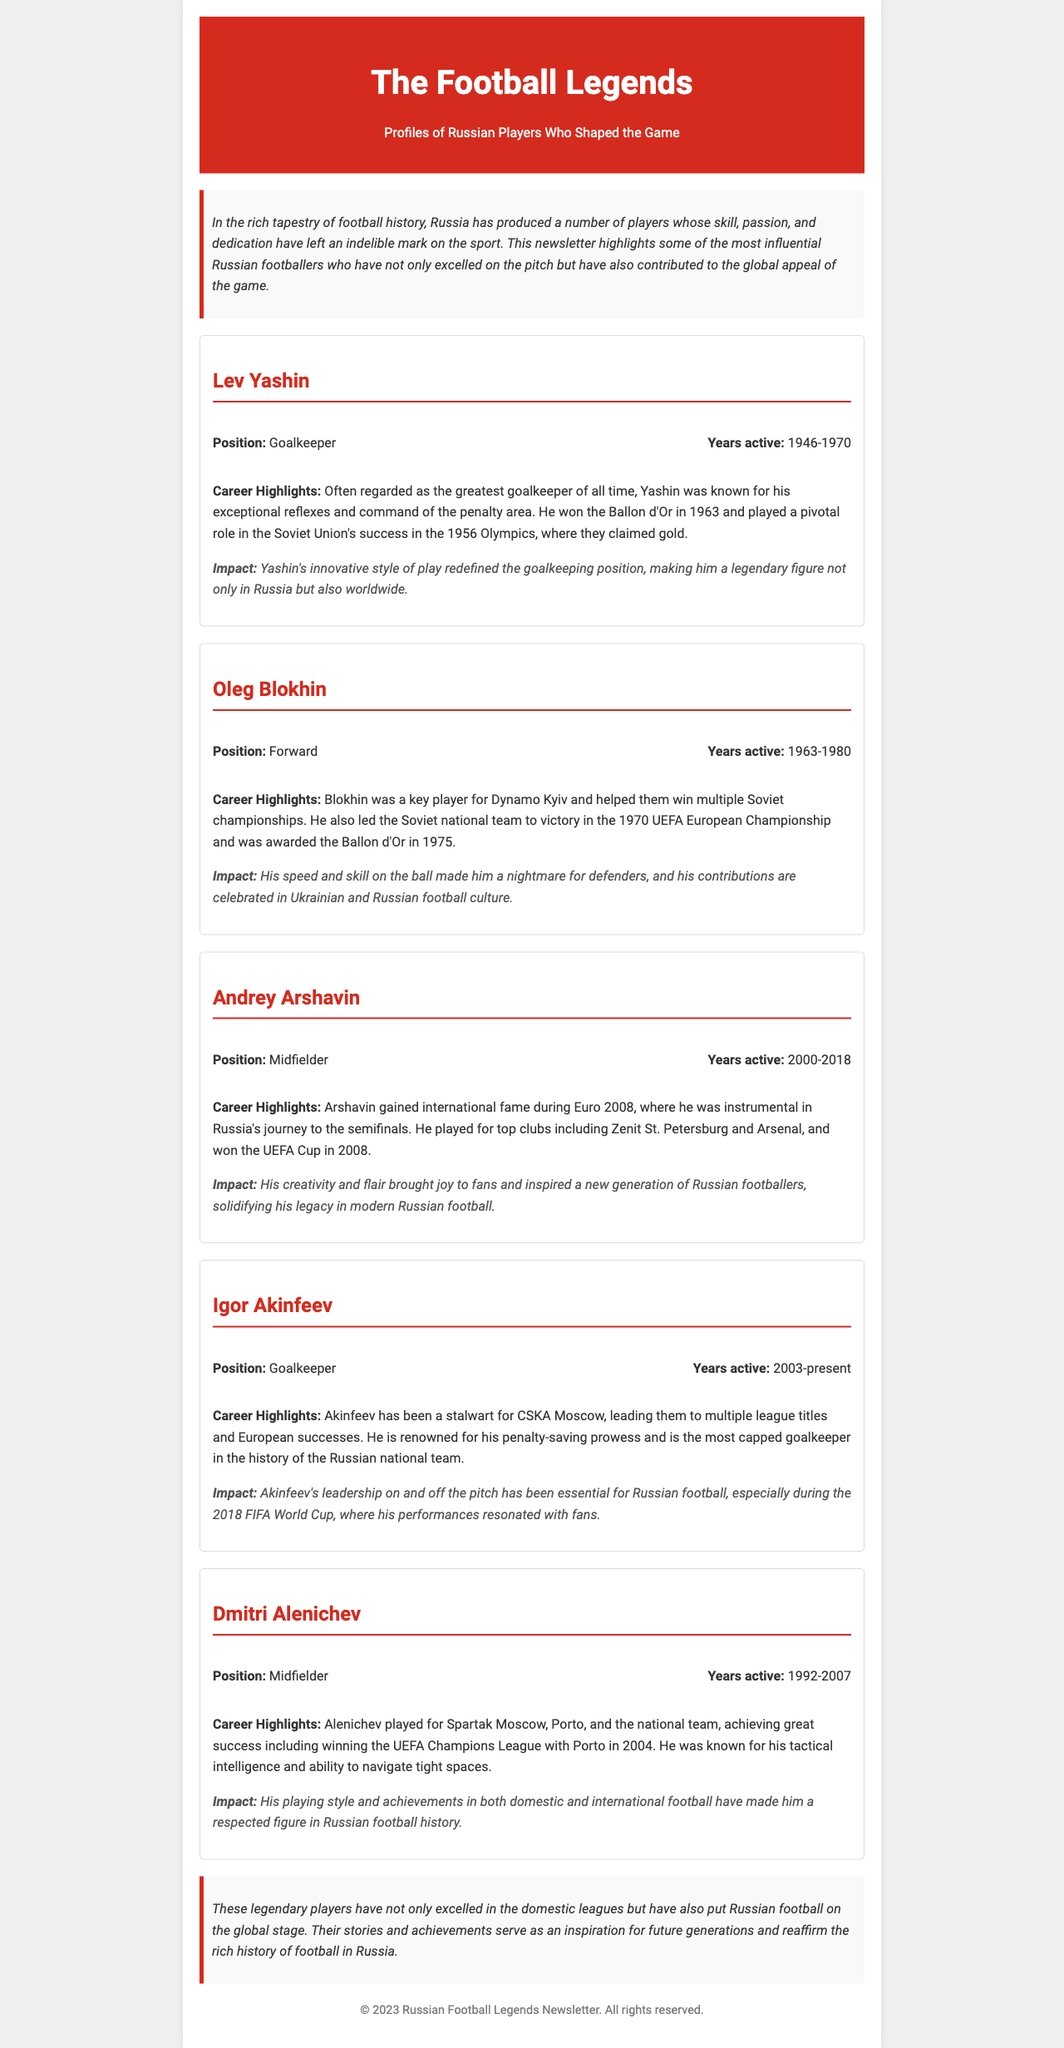what is the title of the newsletter? The title of the newsletter, which reflects its focus on football, is prominently displayed at the top of the document.
Answer: The Football Legends: Russian Players Who Shaped the Game how many players are highlighted in the document? The document features profiles of five influential Russian footballers, which are individually detailed in separate sections.
Answer: Five who won the Ballon d'Or in 1963? The document states that Lev Yashin is recognized for winning the Ballon d'Or in 1963, marking a significant accolade in his career.
Answer: Lev Yashin which player is currently active? The information in the document indicates that Igor Akinfeev is the player whose career is mentioned as currently active, as of the last update in the document.
Answer: Igor Akinfeev what position did Oleg Blokhin play? The document specifies that Oleg Blokhin's position during his career was that of a forward, which is highlighted in his profile section.
Answer: Forward which notable achievement is associated with Andrey Arshavin? The document highlights Andrey Arshavin's instrumental role during Euro 2008, which is a key moment in his career.
Answer: Euro 2008 what year did Dmitri Alenichev start his career? The start year of Dmitri Alenichev's career is indicated in the document, defining his active years in professional football.
Answer: 1992 what is the primary focus of the newsletter? The newsletter aims to showcase and celebrate the significant contributions of Russian football players to the sport.
Answer: Profiles of Russian Players Who Shaped the Game 